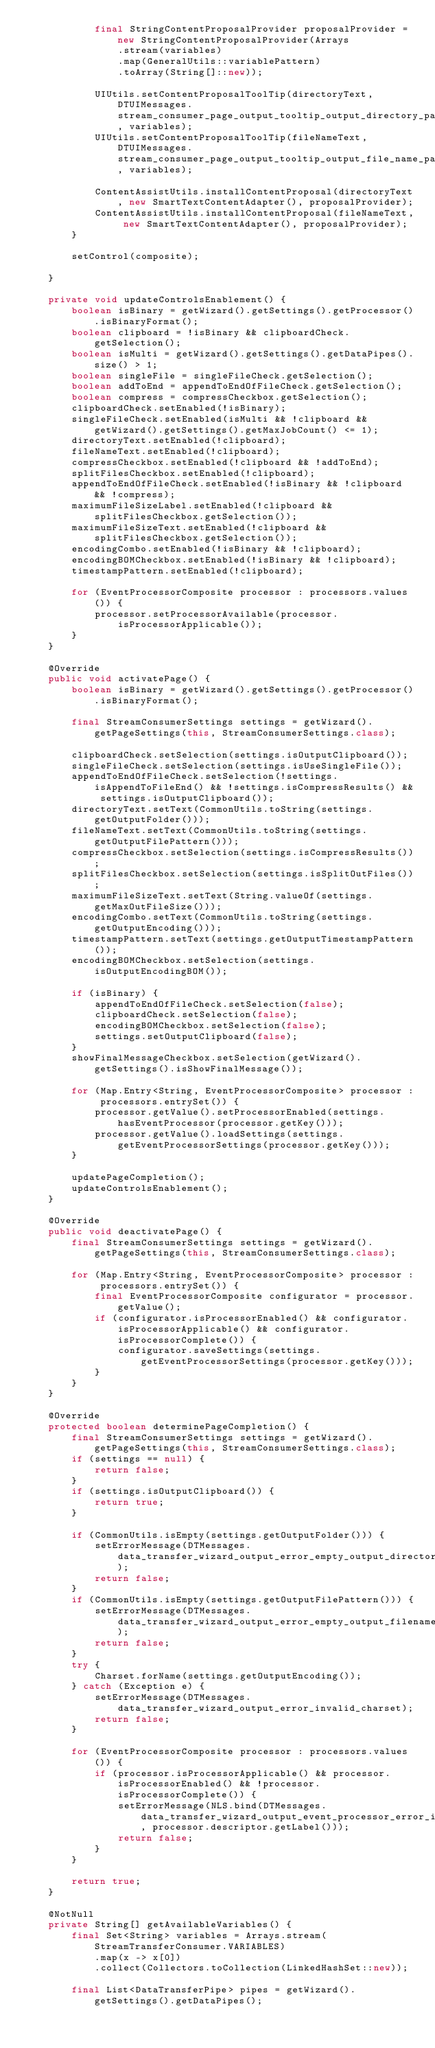<code> <loc_0><loc_0><loc_500><loc_500><_Java_>            final StringContentProposalProvider proposalProvider = new StringContentProposalProvider(Arrays
                .stream(variables)
                .map(GeneralUtils::variablePattern)
                .toArray(String[]::new));

            UIUtils.setContentProposalToolTip(directoryText, DTUIMessages.stream_consumer_page_output_tooltip_output_directory_pattern, variables);
            UIUtils.setContentProposalToolTip(fileNameText, DTUIMessages.stream_consumer_page_output_tooltip_output_file_name_pattern, variables);

            ContentAssistUtils.installContentProposal(directoryText, new SmartTextContentAdapter(), proposalProvider);
            ContentAssistUtils.installContentProposal(fileNameText, new SmartTextContentAdapter(), proposalProvider);
        }

        setControl(composite);

    }

    private void updateControlsEnablement() {
        boolean isBinary = getWizard().getSettings().getProcessor().isBinaryFormat();
        boolean clipboard = !isBinary && clipboardCheck.getSelection();
        boolean isMulti = getWizard().getSettings().getDataPipes().size() > 1;
        boolean singleFile = singleFileCheck.getSelection();
        boolean addToEnd = appendToEndOfFileCheck.getSelection();
        boolean compress = compressCheckbox.getSelection();
        clipboardCheck.setEnabled(!isBinary);
        singleFileCheck.setEnabled(isMulti && !clipboard && getWizard().getSettings().getMaxJobCount() <= 1);
        directoryText.setEnabled(!clipboard);
        fileNameText.setEnabled(!clipboard);
        compressCheckbox.setEnabled(!clipboard && !addToEnd);
        splitFilesCheckbox.setEnabled(!clipboard);
        appendToEndOfFileCheck.setEnabled(!isBinary && !clipboard && !compress);
        maximumFileSizeLabel.setEnabled(!clipboard && splitFilesCheckbox.getSelection());
        maximumFileSizeText.setEnabled(!clipboard && splitFilesCheckbox.getSelection());
        encodingCombo.setEnabled(!isBinary && !clipboard);
        encodingBOMCheckbox.setEnabled(!isBinary && !clipboard);
        timestampPattern.setEnabled(!clipboard);

        for (EventProcessorComposite processor : processors.values()) {
            processor.setProcessorAvailable(processor.isProcessorApplicable());
        }
    }

    @Override
    public void activatePage() {
        boolean isBinary = getWizard().getSettings().getProcessor().isBinaryFormat();

        final StreamConsumerSettings settings = getWizard().getPageSettings(this, StreamConsumerSettings.class);

        clipboardCheck.setSelection(settings.isOutputClipboard());
        singleFileCheck.setSelection(settings.isUseSingleFile());
        appendToEndOfFileCheck.setSelection(!settings.isAppendToFileEnd() && !settings.isCompressResults() && settings.isOutputClipboard());
        directoryText.setText(CommonUtils.toString(settings.getOutputFolder()));
        fileNameText.setText(CommonUtils.toString(settings.getOutputFilePattern()));
        compressCheckbox.setSelection(settings.isCompressResults());
        splitFilesCheckbox.setSelection(settings.isSplitOutFiles());
        maximumFileSizeText.setText(String.valueOf(settings.getMaxOutFileSize()));
        encodingCombo.setText(CommonUtils.toString(settings.getOutputEncoding()));
        timestampPattern.setText(settings.getOutputTimestampPattern());
        encodingBOMCheckbox.setSelection(settings.isOutputEncodingBOM());

        if (isBinary) {
            appendToEndOfFileCheck.setSelection(false);
            clipboardCheck.setSelection(false);
            encodingBOMCheckbox.setSelection(false);
            settings.setOutputClipboard(false);
        }
        showFinalMessageCheckbox.setSelection(getWizard().getSettings().isShowFinalMessage());

        for (Map.Entry<String, EventProcessorComposite> processor : processors.entrySet()) {
            processor.getValue().setProcessorEnabled(settings.hasEventProcessor(processor.getKey()));
            processor.getValue().loadSettings(settings.getEventProcessorSettings(processor.getKey()));
        }

        updatePageCompletion();
        updateControlsEnablement();
    }

    @Override
    public void deactivatePage() {
        final StreamConsumerSettings settings = getWizard().getPageSettings(this, StreamConsumerSettings.class);

        for (Map.Entry<String, EventProcessorComposite> processor : processors.entrySet()) {
            final EventProcessorComposite configurator = processor.getValue();
            if (configurator.isProcessorEnabled() && configurator.isProcessorApplicable() && configurator.isProcessorComplete()) {
                configurator.saveSettings(settings.getEventProcessorSettings(processor.getKey()));
            }
        }
    }

    @Override
    protected boolean determinePageCompletion() {
        final StreamConsumerSettings settings = getWizard().getPageSettings(this, StreamConsumerSettings.class);
        if (settings == null) {
            return false;
        }
        if (settings.isOutputClipboard()) {
            return true;
        }

        if (CommonUtils.isEmpty(settings.getOutputFolder())) {
            setErrorMessage(DTMessages.data_transfer_wizard_output_error_empty_output_directory);
            return false;
        }
        if (CommonUtils.isEmpty(settings.getOutputFilePattern())) {
            setErrorMessage(DTMessages.data_transfer_wizard_output_error_empty_output_filename);
            return false;
        }
        try {
            Charset.forName(settings.getOutputEncoding());
        } catch (Exception e) {
            setErrorMessage(DTMessages.data_transfer_wizard_output_error_invalid_charset);
            return false;
        }

        for (EventProcessorComposite processor : processors.values()) {
            if (processor.isProcessorApplicable() && processor.isProcessorEnabled() && !processor.isProcessorComplete()) {
                setErrorMessage(NLS.bind(DTMessages.data_transfer_wizard_output_event_processor_error_incomplete_configuration, processor.descriptor.getLabel()));
                return false;
            }
        }

        return true;
    }

    @NotNull
    private String[] getAvailableVariables() {
        final Set<String> variables = Arrays.stream(StreamTransferConsumer.VARIABLES)
            .map(x -> x[0])
            .collect(Collectors.toCollection(LinkedHashSet::new));

        final List<DataTransferPipe> pipes = getWizard().getSettings().getDataPipes();</code> 